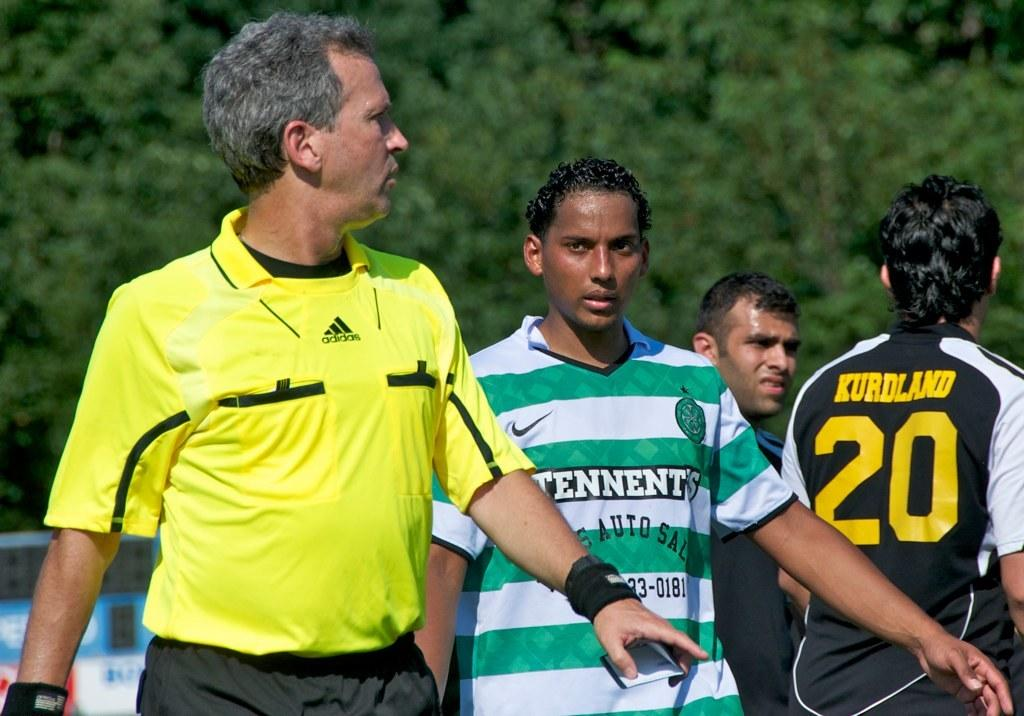How many people are present in the image? There are four men standing in the image. What can be seen in the background of the image? There are trees visible in the background of the image. What type of banana is being held by the man on the left in the image? There is no banana present in the image. What substance is being used by the men in the image? The provided facts do not mention any substance being used by the men in the image. 